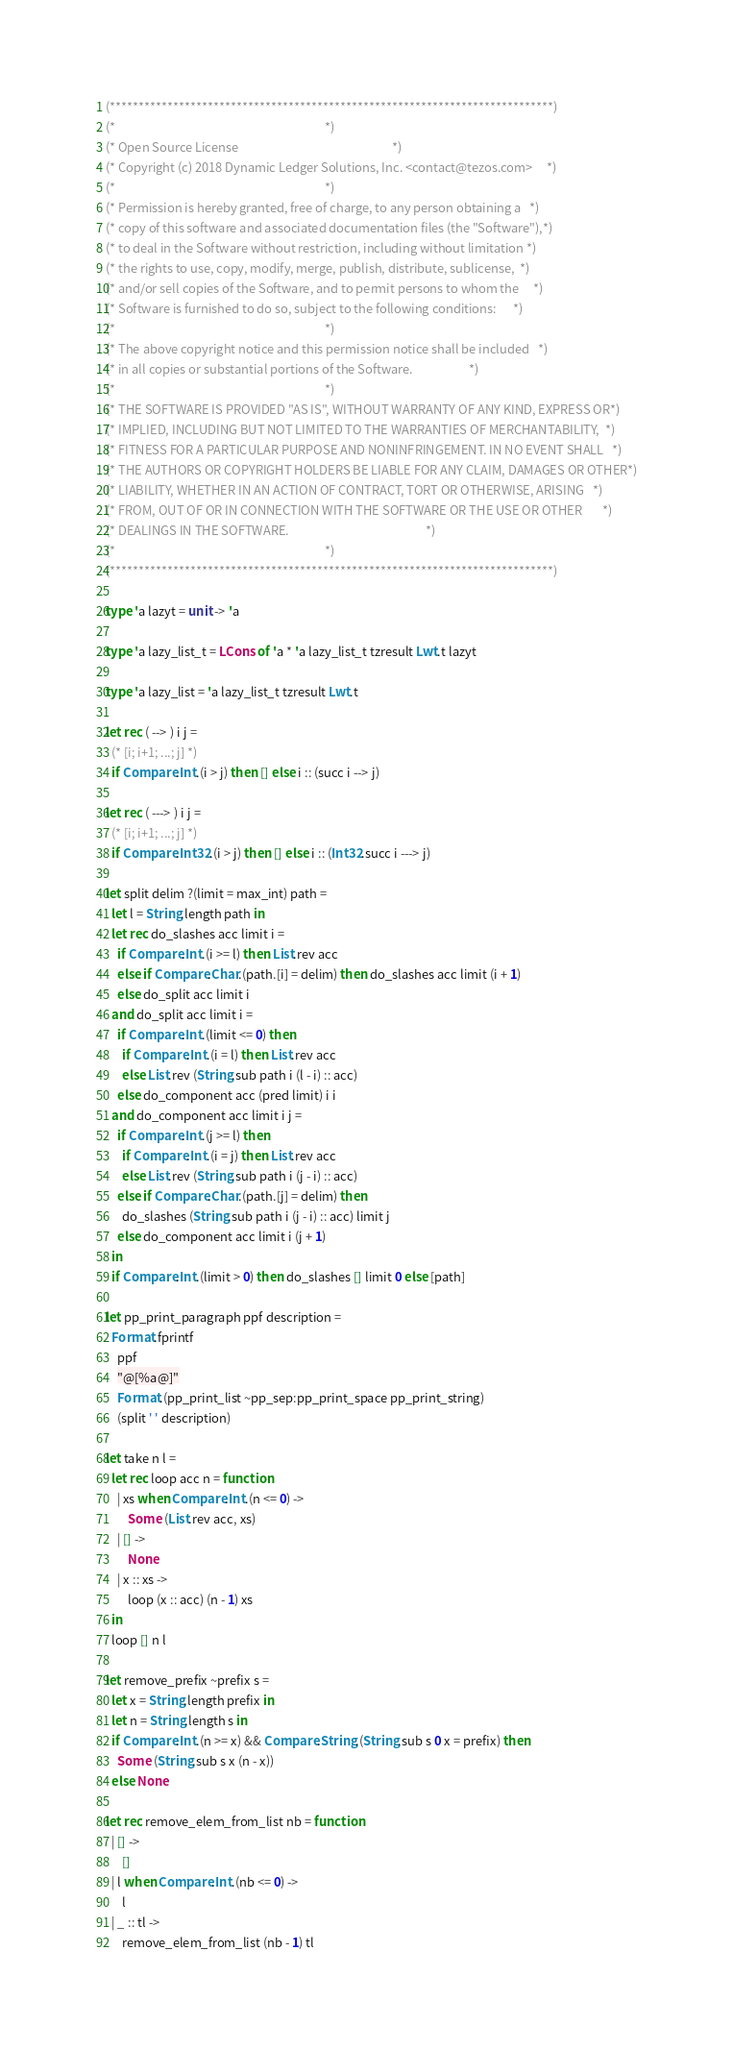Convert code to text. <code><loc_0><loc_0><loc_500><loc_500><_OCaml_>(*****************************************************************************)
(*                                                                           *)
(* Open Source License                                                       *)
(* Copyright (c) 2018 Dynamic Ledger Solutions, Inc. <contact@tezos.com>     *)
(*                                                                           *)
(* Permission is hereby granted, free of charge, to any person obtaining a   *)
(* copy of this software and associated documentation files (the "Software"),*)
(* to deal in the Software without restriction, including without limitation *)
(* the rights to use, copy, modify, merge, publish, distribute, sublicense,  *)
(* and/or sell copies of the Software, and to permit persons to whom the     *)
(* Software is furnished to do so, subject to the following conditions:      *)
(*                                                                           *)
(* The above copyright notice and this permission notice shall be included   *)
(* in all copies or substantial portions of the Software.                    *)
(*                                                                           *)
(* THE SOFTWARE IS PROVIDED "AS IS", WITHOUT WARRANTY OF ANY KIND, EXPRESS OR*)
(* IMPLIED, INCLUDING BUT NOT LIMITED TO THE WARRANTIES OF MERCHANTABILITY,  *)
(* FITNESS FOR A PARTICULAR PURPOSE AND NONINFRINGEMENT. IN NO EVENT SHALL   *)
(* THE AUTHORS OR COPYRIGHT HOLDERS BE LIABLE FOR ANY CLAIM, DAMAGES OR OTHER*)
(* LIABILITY, WHETHER IN AN ACTION OF CONTRACT, TORT OR OTHERWISE, ARISING   *)
(* FROM, OUT OF OR IN CONNECTION WITH THE SOFTWARE OR THE USE OR OTHER       *)
(* DEALINGS IN THE SOFTWARE.                                                 *)
(*                                                                           *)
(*****************************************************************************)

type 'a lazyt = unit -> 'a

type 'a lazy_list_t = LCons of 'a * 'a lazy_list_t tzresult Lwt.t lazyt

type 'a lazy_list = 'a lazy_list_t tzresult Lwt.t

let rec ( --> ) i j =
  (* [i; i+1; ...; j] *)
  if Compare.Int.(i > j) then [] else i :: (succ i --> j)

let rec ( ---> ) i j =
  (* [i; i+1; ...; j] *)
  if Compare.Int32.(i > j) then [] else i :: (Int32.succ i ---> j)

let split delim ?(limit = max_int) path =
  let l = String.length path in
  let rec do_slashes acc limit i =
    if Compare.Int.(i >= l) then List.rev acc
    else if Compare.Char.(path.[i] = delim) then do_slashes acc limit (i + 1)
    else do_split acc limit i
  and do_split acc limit i =
    if Compare.Int.(limit <= 0) then
      if Compare.Int.(i = l) then List.rev acc
      else List.rev (String.sub path i (l - i) :: acc)
    else do_component acc (pred limit) i i
  and do_component acc limit i j =
    if Compare.Int.(j >= l) then
      if Compare.Int.(i = j) then List.rev acc
      else List.rev (String.sub path i (j - i) :: acc)
    else if Compare.Char.(path.[j] = delim) then
      do_slashes (String.sub path i (j - i) :: acc) limit j
    else do_component acc limit i (j + 1)
  in
  if Compare.Int.(limit > 0) then do_slashes [] limit 0 else [path]

let pp_print_paragraph ppf description =
  Format.fprintf
    ppf
    "@[%a@]"
    Format.(pp_print_list ~pp_sep:pp_print_space pp_print_string)
    (split ' ' description)

let take n l =
  let rec loop acc n = function
    | xs when Compare.Int.(n <= 0) ->
        Some (List.rev acc, xs)
    | [] ->
        None
    | x :: xs ->
        loop (x :: acc) (n - 1) xs
  in
  loop [] n l

let remove_prefix ~prefix s =
  let x = String.length prefix in
  let n = String.length s in
  if Compare.Int.(n >= x) && Compare.String.(String.sub s 0 x = prefix) then
    Some (String.sub s x (n - x))
  else None

let rec remove_elem_from_list nb = function
  | [] ->
      []
  | l when Compare.Int.(nb <= 0) ->
      l
  | _ :: tl ->
      remove_elem_from_list (nb - 1) tl
</code> 